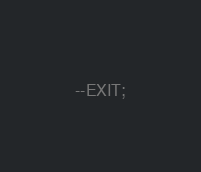<code> <loc_0><loc_0><loc_500><loc_500><_SQL_>
--EXIT;
</code> 